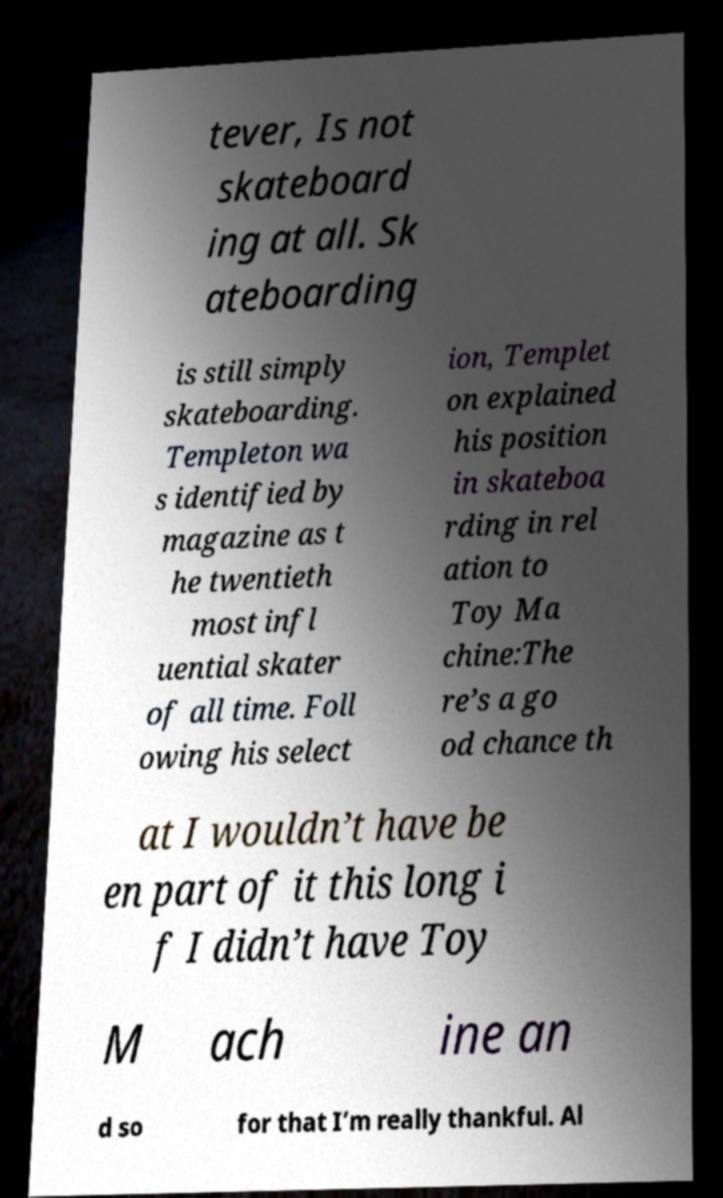Can you read and provide the text displayed in the image?This photo seems to have some interesting text. Can you extract and type it out for me? tever, Is not skateboard ing at all. Sk ateboarding is still simply skateboarding. Templeton wa s identified by magazine as t he twentieth most infl uential skater of all time. Foll owing his select ion, Templet on explained his position in skateboa rding in rel ation to Toy Ma chine:The re’s a go od chance th at I wouldn’t have be en part of it this long i f I didn’t have Toy M ach ine an d so for that I’m really thankful. Al 